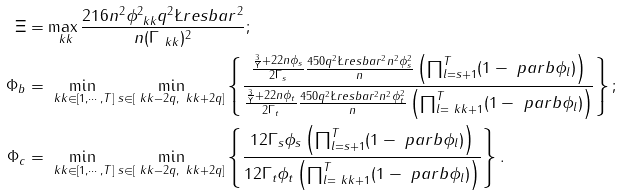<formula> <loc_0><loc_0><loc_500><loc_500>\Xi & = \max _ { \ k k } \frac { 2 1 6 n ^ { 2 } \phi _ { \ k k } ^ { 2 } q ^ { 2 } \L r e s b a r ^ { 2 } } { n ( \Gamma _ { \ k k } ) ^ { 2 } } ; \\ \Phi _ { b } & = \min _ { \ k k \in [ 1 , \cdots , T ] } \min _ { s \in [ \ k k - 2 q , \ k k + 2 q ] } \left \{ \frac { \frac { \frac { 3 } { \Upsilon } + 2 2 n \phi _ { s } } { 2 \Gamma _ { s } } \frac { 4 5 0 q ^ { 2 } \L r e s b a r ^ { 2 } n ^ { 2 } \phi _ { s } ^ { 2 } } { n } \left ( \prod _ { l = s + 1 } ^ { T } ( 1 - \ p a r b \phi _ { l } ) \right ) } { \frac { \frac { 3 } { \Upsilon } + 2 2 n \phi _ { t } } { 2 \Gamma _ { t } } \frac { 4 5 0 q ^ { 2 } \L r e s b a r ^ { 2 } n ^ { 2 } \phi _ { t } ^ { 2 } } { n } \left ( \prod _ { l = \ k k + 1 } ^ { T } ( 1 - \ p a r b \phi _ { l } ) \right ) } \right \} ; \\ \Phi _ { c } & = \min _ { \ k k \in [ 1 , \cdots , T ] } \min _ { s \in [ \ k k - 2 q , \ k k + 2 q ] } \left \{ \frac { 1 2 \Gamma _ { s } \phi _ { s } \left ( \prod _ { l = s + 1 } ^ { T } ( 1 - \ p a r b \phi _ { l } ) \right ) } { 1 2 \Gamma _ { t } \phi _ { t } \left ( \prod _ { l = \ k k + 1 } ^ { T } ( 1 - \ p a r b \phi _ { l } ) \right ) } \right \} .</formula> 